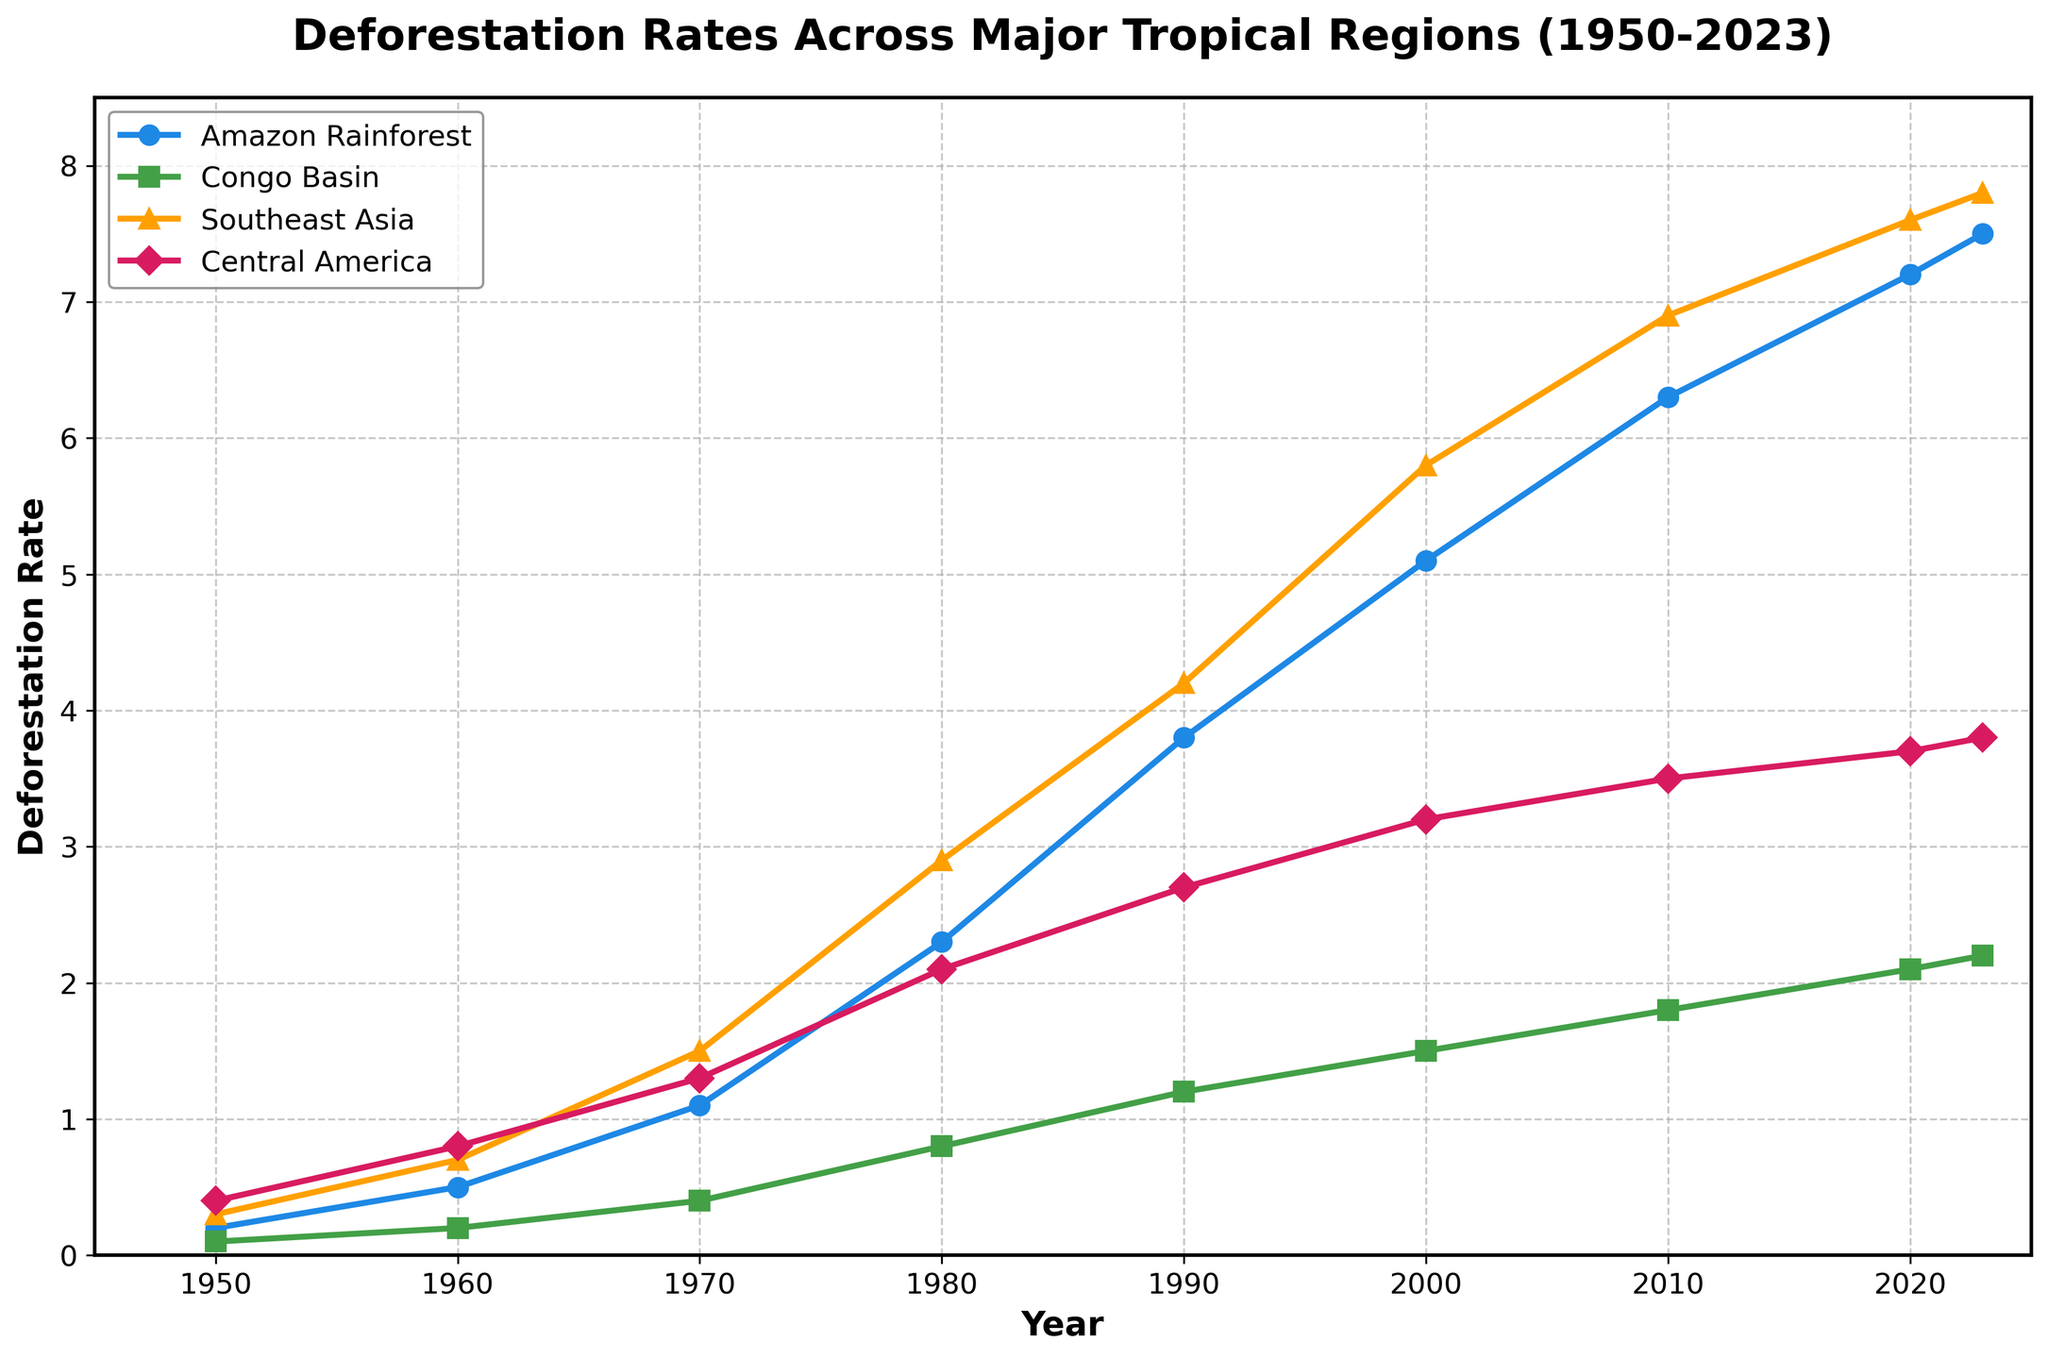What's the deforestation rate in the Amazon Rainforest in 1980? Look at the point on the line corresponding to the Amazon Rainforest (marked by blue circles) for the year 1980. The y-value at that point represents the deforestation rate.
Answer: 2.3 Which region had the highest deforestation rate in 2020? Compare the y-values of the lines for each region (marked by different colors and shapes) at the year 2020. The region with the highest y-value has the highest deforestation rate.
Answer: Southeast Asia By how much did the deforestation rate in Central America increase from 1950 to 2023? Find the y-values for Central America (marked by pink diamonds) at the years 1950 and 2023. Subtract the 1950 value from the 2023 value to get the increase.
Answer: 3.4 Which region experienced the largest increase in deforestation rate between 1950 and 2023? Calculate the difference in y-values between 1950 and 2023 for each region. Compare these differences to find the largest.
Answer: Amazon Rainforest What is the average deforestation rate for the Congo Basin from 1950 to 2023? Add the y-values for the Congo Basin (marked by green squares) for all the years, then divide by the number of years.
Answer: 1.3 Compare the deforestation rates of the Amazon Rainforest and Southeast Asia in 2010. Which was higher? Look at the y-values for the Amazon Rainforest (blue circles) and Southeast Asia (orange triangles) for the year 2010, then compare them.
Answer: Southeast Asia What is the trend in deforestation rate in the Congo Basin from 1950 to 2023? Observe the slope of the line corresponding to the Congo Basin (green squares) from 1950 to 2023. A general upward slope indicates an increasing trend.
Answer: Increasing Between which two consecutive decades did the deforestation rate in Southeast Asia increase the most? Calculate the difference in y-values for Southeast Asia (orange triangles) between each consecutive decade and compare to find the maximum increase.
Answer: 1970-1980 What is the difference between the deforestation rates in the Amazon Rainforest and the Congo Basin in 2000? Find the y-values for both the Amazon Rainforest (blue circles) and Congo Basin (green squares) in 2000 and subtract the Congo Basin value from the Amazon Rainforest value.
Answer: 3.6 